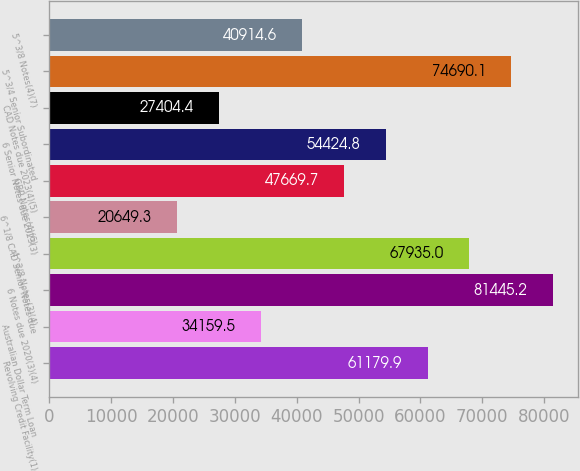Convert chart. <chart><loc_0><loc_0><loc_500><loc_500><bar_chart><fcel>Revolving Credit Facility(1)<fcel>Australian Dollar Term Loan<fcel>6 Notes due 2020(3)(4)<fcel>4^3/8 Notes(3)(4)<fcel>6^1/8 CAD Senior Notes due<fcel>GBP Notes(4)(6)<fcel>6 Senior Notes due 2023(3)<fcel>CAD Notes due 2023(4)(5)<fcel>5^3/4 Senior Subordinated<fcel>5^3/8 Notes(4)(7)<nl><fcel>61179.9<fcel>34159.5<fcel>81445.2<fcel>67935<fcel>20649.3<fcel>47669.7<fcel>54424.8<fcel>27404.4<fcel>74690.1<fcel>40914.6<nl></chart> 